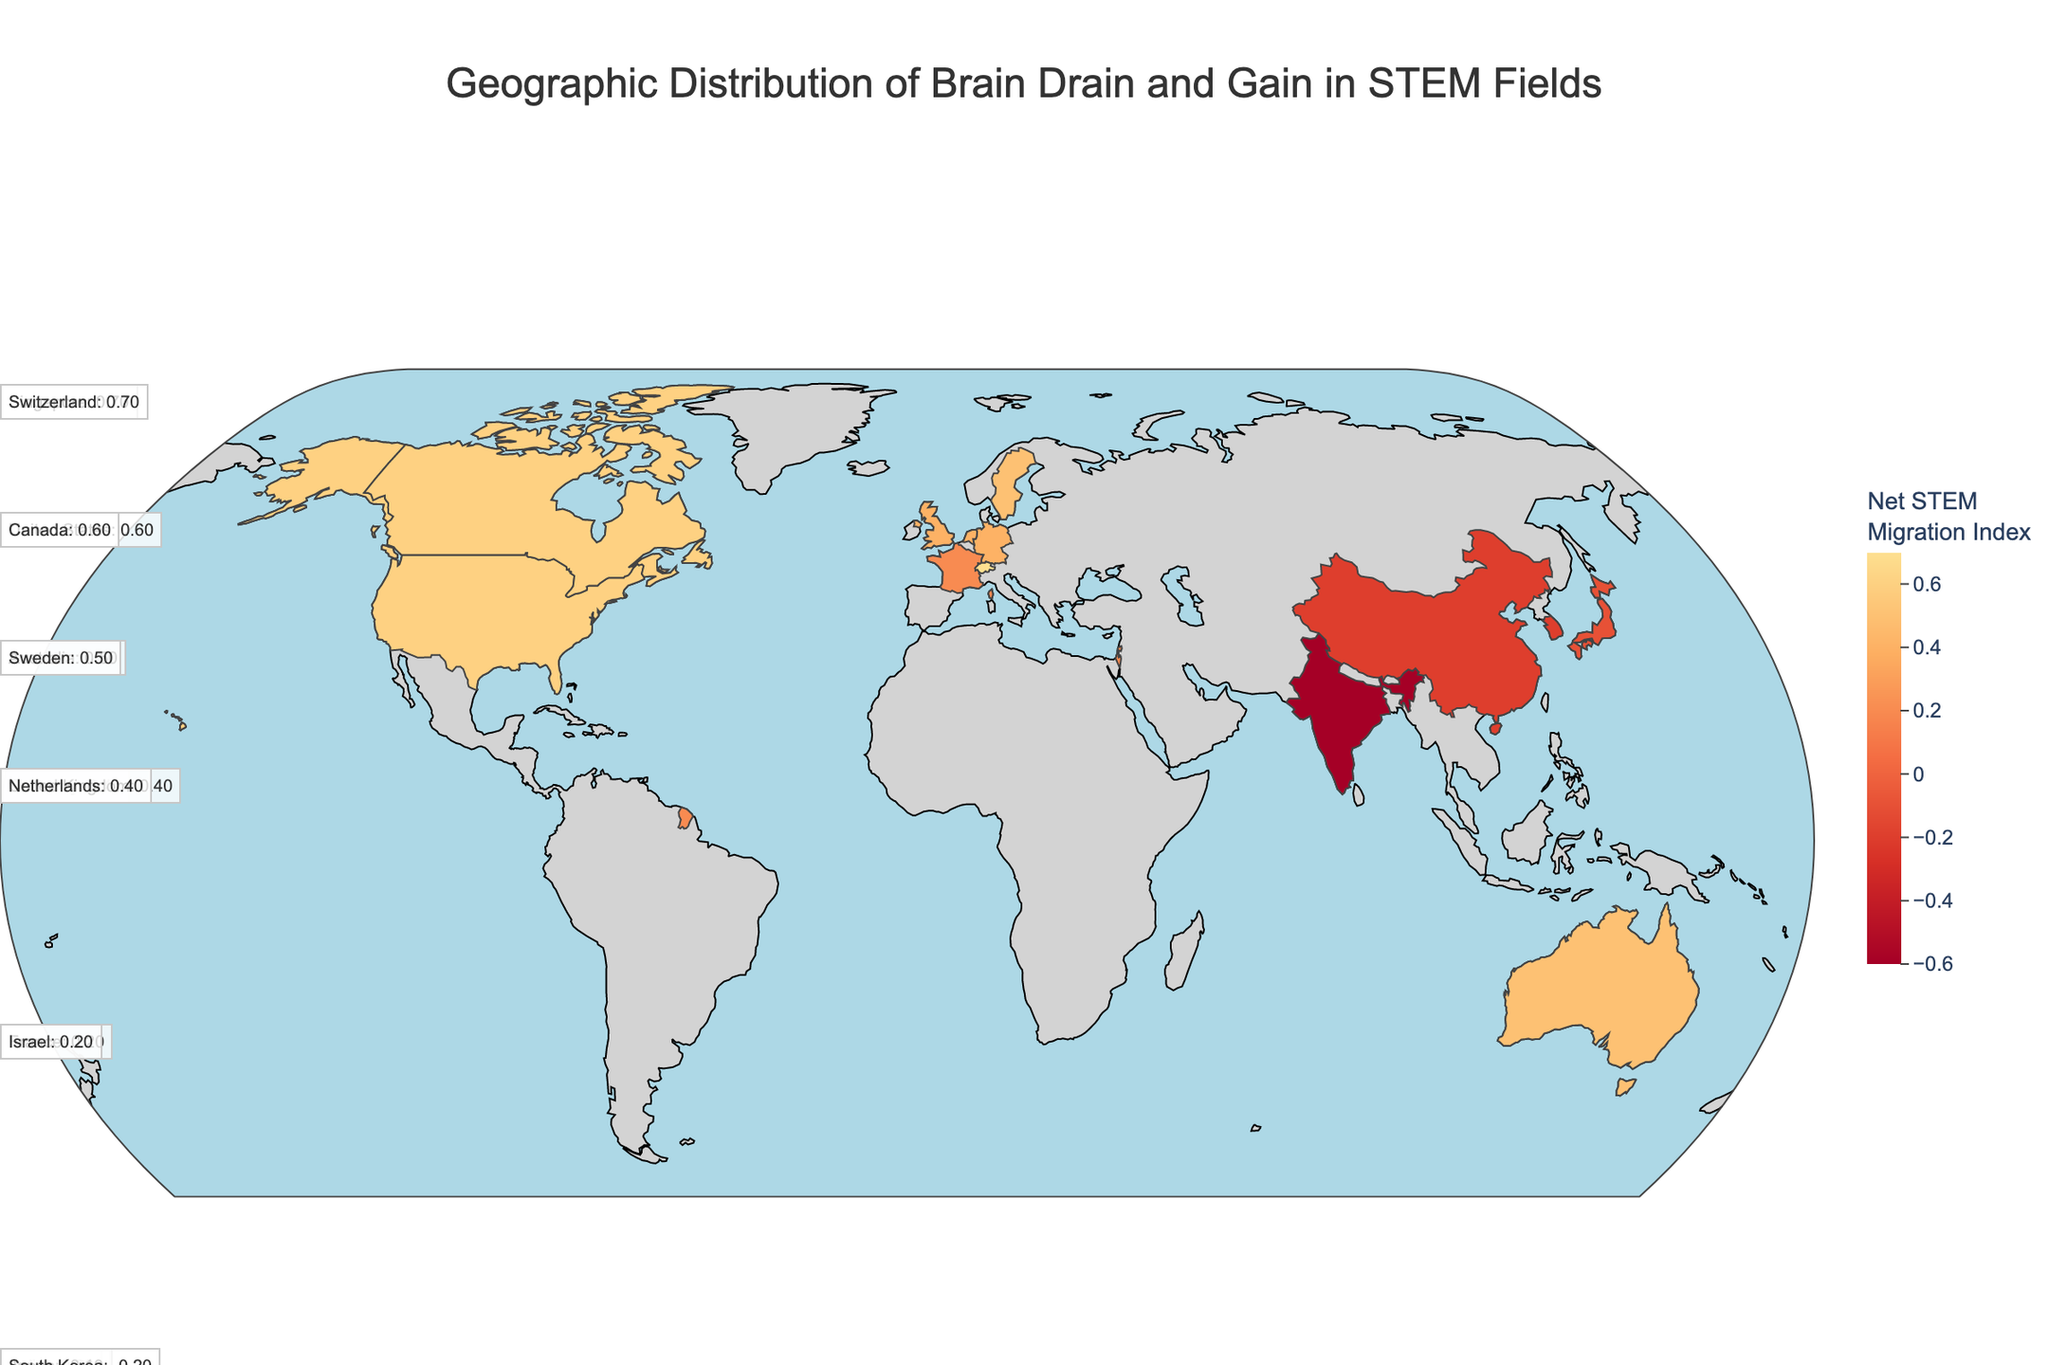What is the title of the geographic plot? The title is prominent at the top of the figure and indicates the primary focus of the visualization.
Answer: Geographic Distribution of Brain Drain and Gain in STEM Fields Which country has the highest Net STEM Migration Index? By examining the color intensity and annotations, we can identify which country has the highest net migration value.
Answer: Switzerland Which three countries have a Net STEM Migration Index of 0.6 or higher? We need to look at the annotations and the plot colors to find countries that meet this threshold.
Answer: United States, Canada, Singapore, Switzerland Compare the Net STEM Migration Index of China and India. We locate China and India in the plot, then compare their indices from the annotations or color intensity.
Answer: Both have negative indices, China has -0.2, and India has -0.6 How does the Net STEM Migration Index of the United States compare with that of Germany? Locate both the United States and Germany in the plot and compare their indices from the annotations.
Answer: The United States has a higher index (0.6) than Germany (0.4) Which countries have a Net STEM Migration Index of exactly 0.4? Look at the annotations and identify countries that show a value of 0.4.
Answer: Germany, United Kingdom, Netherlands What is the total Net STEM Migration Index for countries with negative values? Identify countries with negative indices, sum these values: China (-0.2), India (-0.6), Japan (-0.1), South Korea (-0.2)
Answer: -1.1 From the geographic plot, which country has the lowest Brain Drain Index? Examine the plot annotations or colors that reflect Brain Drain values and identify the country with the lowest index.
Answer: India Based on the color scale, determine which region experiences a positive Net STEM Migration Index overall. Regions with warm colors (e.g., shades of red and yellow) reflect positive values; identify the general pattern from the map.
Answer: North America and parts of Western Europe Comparing Australia and Sweden, which country has a higher Net STEM Migration Index? Locate both countries in the plot and compare their indices.
Answer: Both have the same index (0.5) 